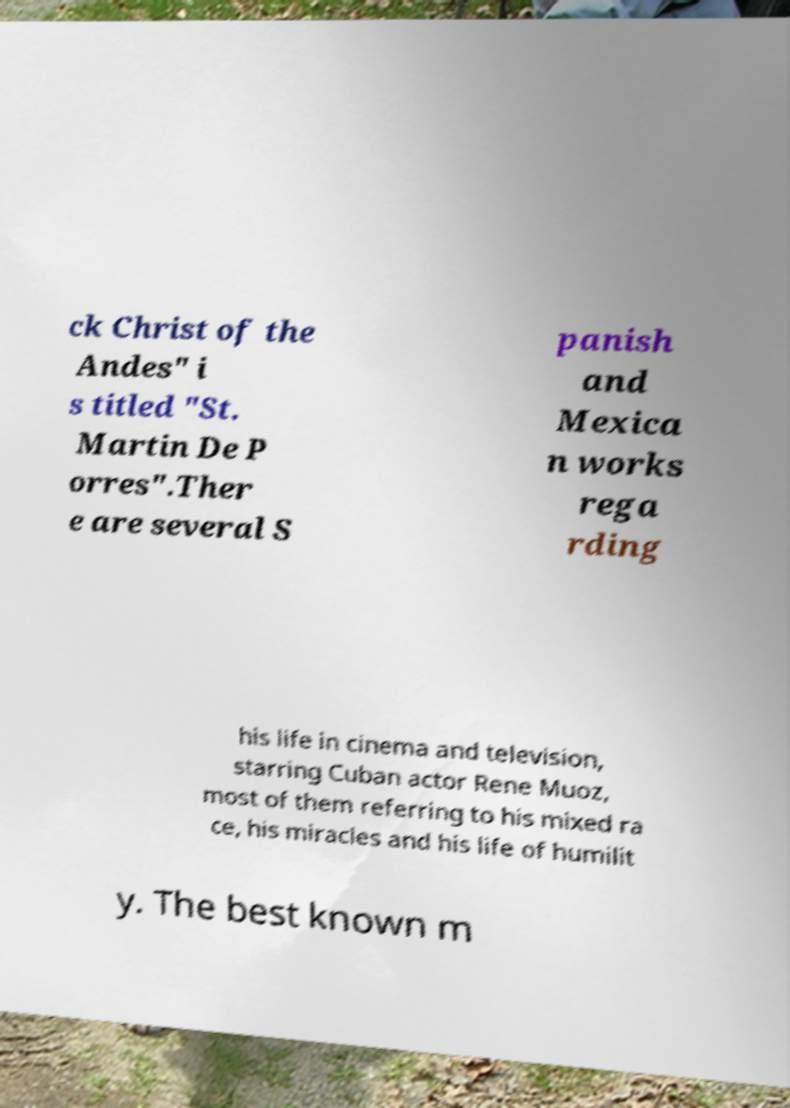For documentation purposes, I need the text within this image transcribed. Could you provide that? ck Christ of the Andes" i s titled "St. Martin De P orres".Ther e are several S panish and Mexica n works rega rding his life in cinema and television, starring Cuban actor Rene Muoz, most of them referring to his mixed ra ce, his miracles and his life of humilit y. The best known m 